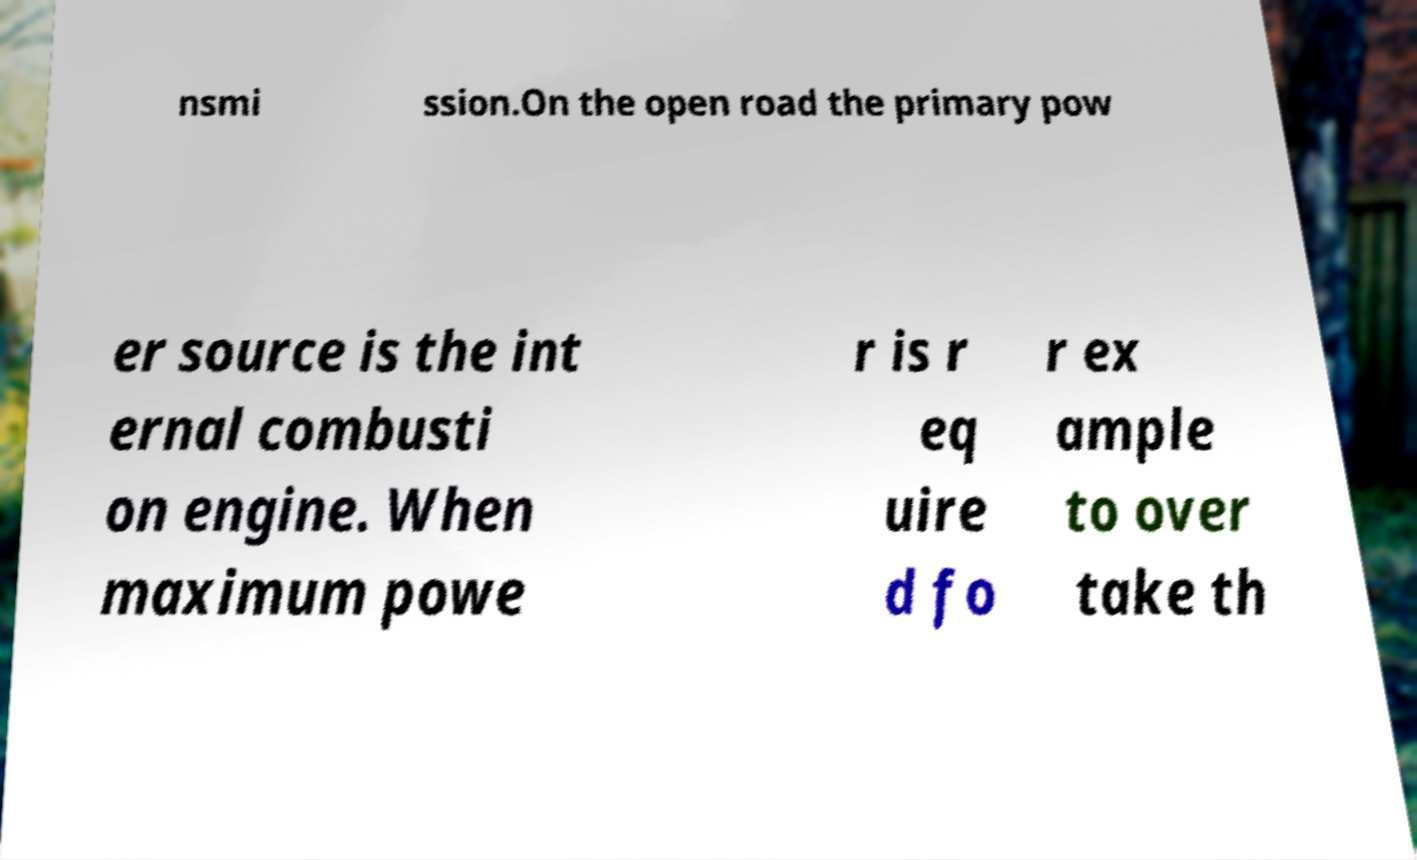Can you read and provide the text displayed in the image?This photo seems to have some interesting text. Can you extract and type it out for me? nsmi ssion.On the open road the primary pow er source is the int ernal combusti on engine. When maximum powe r is r eq uire d fo r ex ample to over take th 